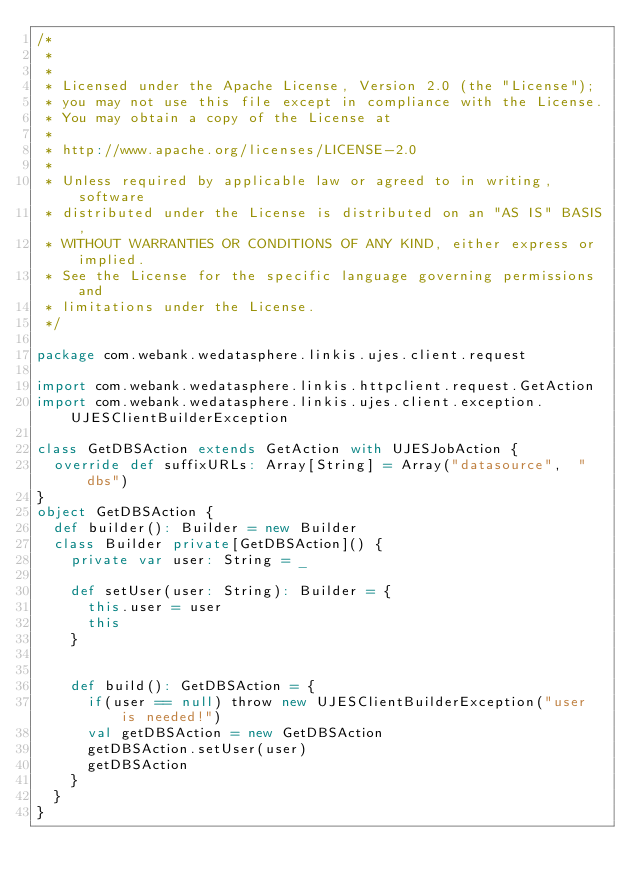<code> <loc_0><loc_0><loc_500><loc_500><_Scala_>/*
 *
 *
 * Licensed under the Apache License, Version 2.0 (the "License");
 * you may not use this file except in compliance with the License.
 * You may obtain a copy of the License at
 *
 * http://www.apache.org/licenses/LICENSE-2.0
 *
 * Unless required by applicable law or agreed to in writing, software
 * distributed under the License is distributed on an "AS IS" BASIS,
 * WITHOUT WARRANTIES OR CONDITIONS OF ANY KIND, either express or implied.
 * See the License for the specific language governing permissions and
 * limitations under the License.
 */

package com.webank.wedatasphere.linkis.ujes.client.request

import com.webank.wedatasphere.linkis.httpclient.request.GetAction
import com.webank.wedatasphere.linkis.ujes.client.exception.UJESClientBuilderException

class GetDBSAction extends GetAction with UJESJobAction {
  override def suffixURLs: Array[String] = Array("datasource",  "dbs")
}
object GetDBSAction {
  def builder(): Builder = new Builder
  class Builder private[GetDBSAction]() {
    private var user: String = _

    def setUser(user: String): Builder = {
      this.user = user
      this
    }


    def build(): GetDBSAction = {
      if(user == null) throw new UJESClientBuilderException("user is needed!")
      val getDBSAction = new GetDBSAction
      getDBSAction.setUser(user)
      getDBSAction
    }
  }
}</code> 